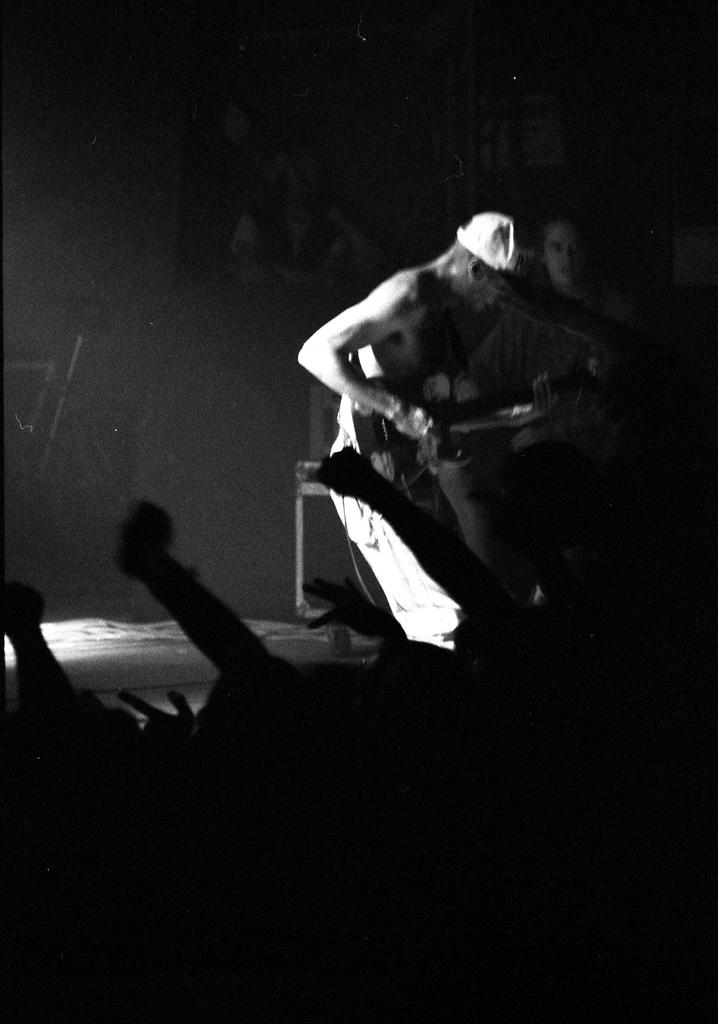What is the color scheme of the image? The image is black and white. What is the main subject of the image? There is a person standing on a stage in the image. What type of dog can be seen playing with a plastic toy in the image? There is no dog or plastic toy present in the image; it features a person standing on a stage. What cut of beef is being served on a plate in the image? There is no plate or beef present in the image; it is a black and white image of a person standing on a stage. 